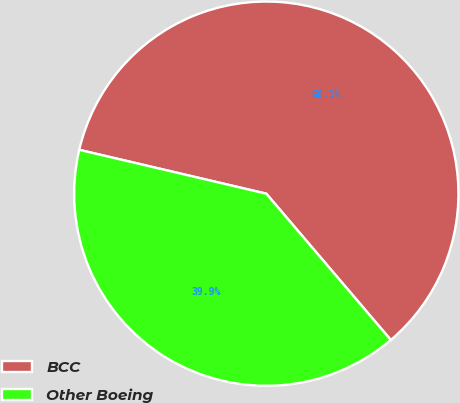Convert chart to OTSL. <chart><loc_0><loc_0><loc_500><loc_500><pie_chart><fcel>BCC<fcel>Other Boeing<nl><fcel>60.11%<fcel>39.89%<nl></chart> 